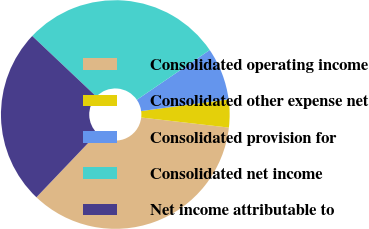Convert chart to OTSL. <chart><loc_0><loc_0><loc_500><loc_500><pie_chart><fcel>Consolidated operating income<fcel>Consolidated other expense net<fcel>Consolidated provision for<fcel>Consolidated net income<fcel>Net income attributable to<nl><fcel>35.3%<fcel>3.94%<fcel>7.42%<fcel>28.41%<fcel>24.93%<nl></chart> 